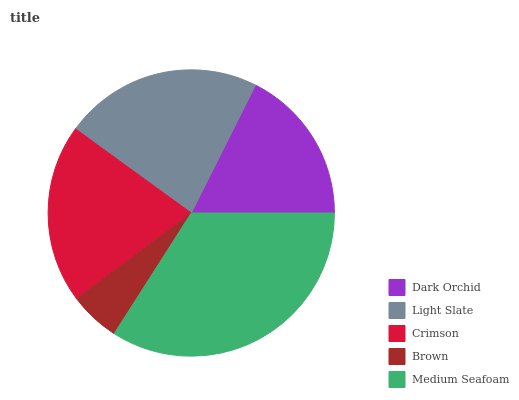Is Brown the minimum?
Answer yes or no. Yes. Is Medium Seafoam the maximum?
Answer yes or no. Yes. Is Light Slate the minimum?
Answer yes or no. No. Is Light Slate the maximum?
Answer yes or no. No. Is Light Slate greater than Dark Orchid?
Answer yes or no. Yes. Is Dark Orchid less than Light Slate?
Answer yes or no. Yes. Is Dark Orchid greater than Light Slate?
Answer yes or no. No. Is Light Slate less than Dark Orchid?
Answer yes or no. No. Is Crimson the high median?
Answer yes or no. Yes. Is Crimson the low median?
Answer yes or no. Yes. Is Dark Orchid the high median?
Answer yes or no. No. Is Medium Seafoam the low median?
Answer yes or no. No. 